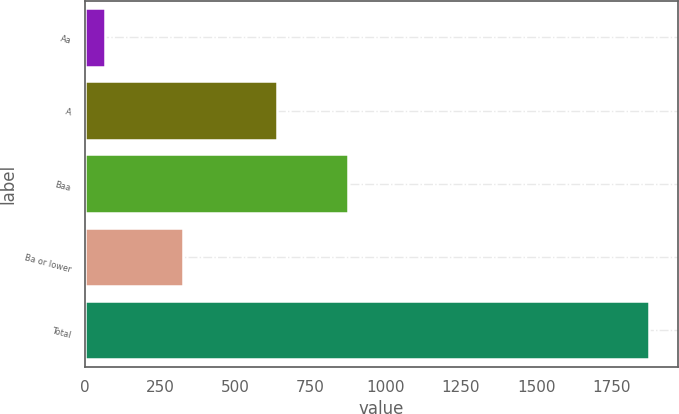Convert chart. <chart><loc_0><loc_0><loc_500><loc_500><bar_chart><fcel>Aa<fcel>A<fcel>Baa<fcel>Ba or lower<fcel>Total<nl><fcel>66<fcel>639<fcel>873<fcel>325<fcel>1877<nl></chart> 